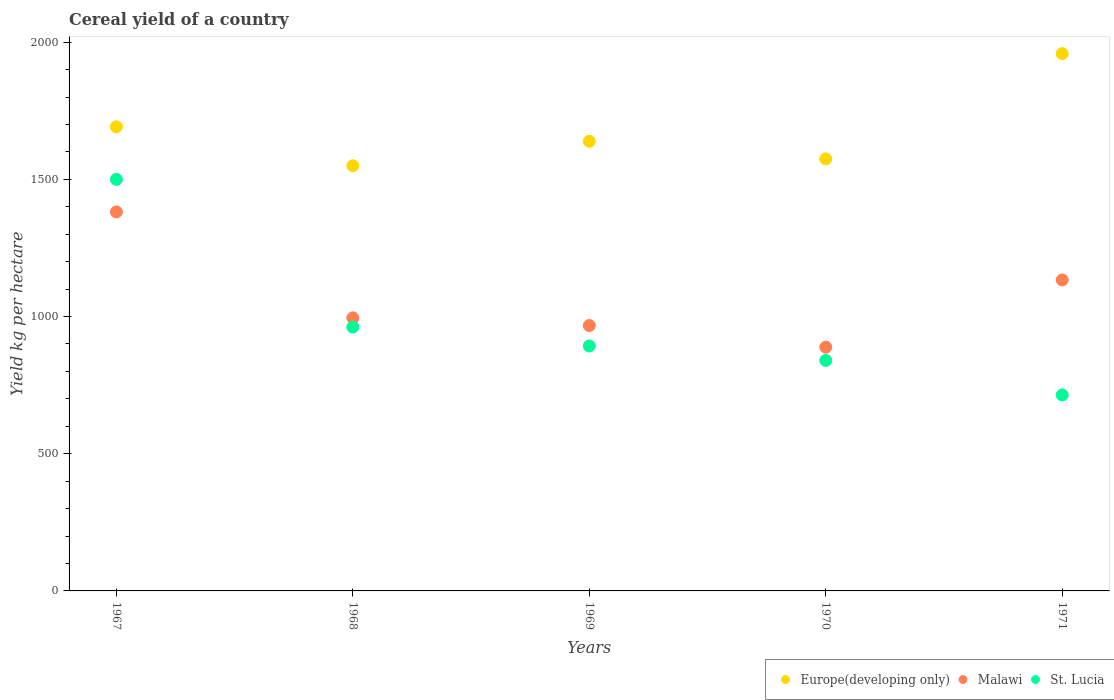Is the number of dotlines equal to the number of legend labels?
Offer a very short reply. Yes. What is the total cereal yield in Malawi in 1971?
Give a very brief answer. 1133.38. Across all years, what is the maximum total cereal yield in Malawi?
Make the answer very short. 1381.3. Across all years, what is the minimum total cereal yield in Malawi?
Your response must be concise. 888.41. In which year was the total cereal yield in Malawi maximum?
Make the answer very short. 1967. In which year was the total cereal yield in Europe(developing only) minimum?
Your response must be concise. 1968. What is the total total cereal yield in Malawi in the graph?
Provide a short and direct response. 5365.64. What is the difference between the total cereal yield in St. Lucia in 1969 and that in 1970?
Offer a terse response. 52.86. What is the difference between the total cereal yield in St. Lucia in 1971 and the total cereal yield in Europe(developing only) in 1967?
Give a very brief answer. -977.36. What is the average total cereal yield in Malawi per year?
Offer a terse response. 1073.13. In the year 1970, what is the difference between the total cereal yield in Malawi and total cereal yield in Europe(developing only)?
Offer a terse response. -686.15. In how many years, is the total cereal yield in Malawi greater than 500 kg per hectare?
Ensure brevity in your answer.  5. What is the ratio of the total cereal yield in St. Lucia in 1967 to that in 1969?
Offer a very short reply. 1.68. Is the total cereal yield in Malawi in 1969 less than that in 1971?
Your response must be concise. Yes. What is the difference between the highest and the second highest total cereal yield in Malawi?
Offer a very short reply. 247.92. What is the difference between the highest and the lowest total cereal yield in Malawi?
Offer a very short reply. 492.89. Is the sum of the total cereal yield in Malawi in 1969 and 1971 greater than the maximum total cereal yield in Europe(developing only) across all years?
Your answer should be compact. Yes. Does the total cereal yield in Europe(developing only) monotonically increase over the years?
Your answer should be compact. No. Is the total cereal yield in Europe(developing only) strictly greater than the total cereal yield in St. Lucia over the years?
Offer a terse response. Yes. What is the title of the graph?
Keep it short and to the point. Cereal yield of a country. What is the label or title of the X-axis?
Your response must be concise. Years. What is the label or title of the Y-axis?
Keep it short and to the point. Yield kg per hectare. What is the Yield kg per hectare of Europe(developing only) in 1967?
Keep it short and to the point. 1691.65. What is the Yield kg per hectare of Malawi in 1967?
Provide a succinct answer. 1381.3. What is the Yield kg per hectare of St. Lucia in 1967?
Make the answer very short. 1500. What is the Yield kg per hectare of Europe(developing only) in 1968?
Offer a terse response. 1549.55. What is the Yield kg per hectare in Malawi in 1968?
Ensure brevity in your answer.  995.26. What is the Yield kg per hectare in St. Lucia in 1968?
Your response must be concise. 961.54. What is the Yield kg per hectare in Europe(developing only) in 1969?
Offer a very short reply. 1638.79. What is the Yield kg per hectare in Malawi in 1969?
Your answer should be very brief. 967.29. What is the Yield kg per hectare in St. Lucia in 1969?
Give a very brief answer. 892.86. What is the Yield kg per hectare of Europe(developing only) in 1970?
Your answer should be compact. 1574.56. What is the Yield kg per hectare in Malawi in 1970?
Your answer should be very brief. 888.41. What is the Yield kg per hectare of St. Lucia in 1970?
Ensure brevity in your answer.  840. What is the Yield kg per hectare of Europe(developing only) in 1971?
Keep it short and to the point. 1958.18. What is the Yield kg per hectare in Malawi in 1971?
Give a very brief answer. 1133.38. What is the Yield kg per hectare in St. Lucia in 1971?
Your answer should be compact. 714.29. Across all years, what is the maximum Yield kg per hectare in Europe(developing only)?
Offer a terse response. 1958.18. Across all years, what is the maximum Yield kg per hectare of Malawi?
Offer a very short reply. 1381.3. Across all years, what is the maximum Yield kg per hectare in St. Lucia?
Make the answer very short. 1500. Across all years, what is the minimum Yield kg per hectare of Europe(developing only)?
Give a very brief answer. 1549.55. Across all years, what is the minimum Yield kg per hectare of Malawi?
Give a very brief answer. 888.41. Across all years, what is the minimum Yield kg per hectare in St. Lucia?
Provide a short and direct response. 714.29. What is the total Yield kg per hectare in Europe(developing only) in the graph?
Ensure brevity in your answer.  8412.72. What is the total Yield kg per hectare of Malawi in the graph?
Ensure brevity in your answer.  5365.64. What is the total Yield kg per hectare in St. Lucia in the graph?
Ensure brevity in your answer.  4908.68. What is the difference between the Yield kg per hectare in Europe(developing only) in 1967 and that in 1968?
Your answer should be very brief. 142.1. What is the difference between the Yield kg per hectare in Malawi in 1967 and that in 1968?
Your response must be concise. 386.05. What is the difference between the Yield kg per hectare of St. Lucia in 1967 and that in 1968?
Offer a very short reply. 538.46. What is the difference between the Yield kg per hectare in Europe(developing only) in 1967 and that in 1969?
Keep it short and to the point. 52.86. What is the difference between the Yield kg per hectare in Malawi in 1967 and that in 1969?
Your response must be concise. 414.01. What is the difference between the Yield kg per hectare in St. Lucia in 1967 and that in 1969?
Offer a terse response. 607.14. What is the difference between the Yield kg per hectare of Europe(developing only) in 1967 and that in 1970?
Make the answer very short. 117.09. What is the difference between the Yield kg per hectare of Malawi in 1967 and that in 1970?
Your answer should be compact. 492.89. What is the difference between the Yield kg per hectare of St. Lucia in 1967 and that in 1970?
Your response must be concise. 660. What is the difference between the Yield kg per hectare of Europe(developing only) in 1967 and that in 1971?
Provide a short and direct response. -266.53. What is the difference between the Yield kg per hectare of Malawi in 1967 and that in 1971?
Ensure brevity in your answer.  247.92. What is the difference between the Yield kg per hectare of St. Lucia in 1967 and that in 1971?
Ensure brevity in your answer.  785.71. What is the difference between the Yield kg per hectare of Europe(developing only) in 1968 and that in 1969?
Offer a terse response. -89.24. What is the difference between the Yield kg per hectare in Malawi in 1968 and that in 1969?
Provide a succinct answer. 27.96. What is the difference between the Yield kg per hectare in St. Lucia in 1968 and that in 1969?
Make the answer very short. 68.68. What is the difference between the Yield kg per hectare in Europe(developing only) in 1968 and that in 1970?
Provide a short and direct response. -25.01. What is the difference between the Yield kg per hectare of Malawi in 1968 and that in 1970?
Your answer should be compact. 106.85. What is the difference between the Yield kg per hectare in St. Lucia in 1968 and that in 1970?
Your answer should be very brief. 121.54. What is the difference between the Yield kg per hectare in Europe(developing only) in 1968 and that in 1971?
Offer a terse response. -408.63. What is the difference between the Yield kg per hectare in Malawi in 1968 and that in 1971?
Make the answer very short. -138.12. What is the difference between the Yield kg per hectare of St. Lucia in 1968 and that in 1971?
Your answer should be compact. 247.25. What is the difference between the Yield kg per hectare of Europe(developing only) in 1969 and that in 1970?
Give a very brief answer. 64.23. What is the difference between the Yield kg per hectare in Malawi in 1969 and that in 1970?
Your answer should be very brief. 78.88. What is the difference between the Yield kg per hectare of St. Lucia in 1969 and that in 1970?
Your response must be concise. 52.86. What is the difference between the Yield kg per hectare in Europe(developing only) in 1969 and that in 1971?
Ensure brevity in your answer.  -319.39. What is the difference between the Yield kg per hectare in Malawi in 1969 and that in 1971?
Provide a short and direct response. -166.09. What is the difference between the Yield kg per hectare of St. Lucia in 1969 and that in 1971?
Offer a very short reply. 178.57. What is the difference between the Yield kg per hectare of Europe(developing only) in 1970 and that in 1971?
Give a very brief answer. -383.62. What is the difference between the Yield kg per hectare of Malawi in 1970 and that in 1971?
Give a very brief answer. -244.97. What is the difference between the Yield kg per hectare in St. Lucia in 1970 and that in 1971?
Keep it short and to the point. 125.71. What is the difference between the Yield kg per hectare of Europe(developing only) in 1967 and the Yield kg per hectare of Malawi in 1968?
Your answer should be compact. 696.39. What is the difference between the Yield kg per hectare in Europe(developing only) in 1967 and the Yield kg per hectare in St. Lucia in 1968?
Offer a very short reply. 730.11. What is the difference between the Yield kg per hectare of Malawi in 1967 and the Yield kg per hectare of St. Lucia in 1968?
Provide a short and direct response. 419.76. What is the difference between the Yield kg per hectare of Europe(developing only) in 1967 and the Yield kg per hectare of Malawi in 1969?
Ensure brevity in your answer.  724.36. What is the difference between the Yield kg per hectare in Europe(developing only) in 1967 and the Yield kg per hectare in St. Lucia in 1969?
Make the answer very short. 798.79. What is the difference between the Yield kg per hectare in Malawi in 1967 and the Yield kg per hectare in St. Lucia in 1969?
Offer a terse response. 488.44. What is the difference between the Yield kg per hectare of Europe(developing only) in 1967 and the Yield kg per hectare of Malawi in 1970?
Give a very brief answer. 803.24. What is the difference between the Yield kg per hectare in Europe(developing only) in 1967 and the Yield kg per hectare in St. Lucia in 1970?
Offer a terse response. 851.65. What is the difference between the Yield kg per hectare in Malawi in 1967 and the Yield kg per hectare in St. Lucia in 1970?
Provide a succinct answer. 541.3. What is the difference between the Yield kg per hectare of Europe(developing only) in 1967 and the Yield kg per hectare of Malawi in 1971?
Your answer should be compact. 558.27. What is the difference between the Yield kg per hectare in Europe(developing only) in 1967 and the Yield kg per hectare in St. Lucia in 1971?
Ensure brevity in your answer.  977.36. What is the difference between the Yield kg per hectare in Malawi in 1967 and the Yield kg per hectare in St. Lucia in 1971?
Make the answer very short. 667.02. What is the difference between the Yield kg per hectare of Europe(developing only) in 1968 and the Yield kg per hectare of Malawi in 1969?
Your answer should be compact. 582.25. What is the difference between the Yield kg per hectare in Europe(developing only) in 1968 and the Yield kg per hectare in St. Lucia in 1969?
Ensure brevity in your answer.  656.69. What is the difference between the Yield kg per hectare in Malawi in 1968 and the Yield kg per hectare in St. Lucia in 1969?
Make the answer very short. 102.4. What is the difference between the Yield kg per hectare in Europe(developing only) in 1968 and the Yield kg per hectare in Malawi in 1970?
Offer a terse response. 661.14. What is the difference between the Yield kg per hectare of Europe(developing only) in 1968 and the Yield kg per hectare of St. Lucia in 1970?
Your response must be concise. 709.55. What is the difference between the Yield kg per hectare of Malawi in 1968 and the Yield kg per hectare of St. Lucia in 1970?
Make the answer very short. 155.26. What is the difference between the Yield kg per hectare of Europe(developing only) in 1968 and the Yield kg per hectare of Malawi in 1971?
Ensure brevity in your answer.  416.16. What is the difference between the Yield kg per hectare in Europe(developing only) in 1968 and the Yield kg per hectare in St. Lucia in 1971?
Give a very brief answer. 835.26. What is the difference between the Yield kg per hectare of Malawi in 1968 and the Yield kg per hectare of St. Lucia in 1971?
Offer a very short reply. 280.97. What is the difference between the Yield kg per hectare of Europe(developing only) in 1969 and the Yield kg per hectare of Malawi in 1970?
Your answer should be compact. 750.38. What is the difference between the Yield kg per hectare in Europe(developing only) in 1969 and the Yield kg per hectare in St. Lucia in 1970?
Give a very brief answer. 798.79. What is the difference between the Yield kg per hectare of Malawi in 1969 and the Yield kg per hectare of St. Lucia in 1970?
Make the answer very short. 127.29. What is the difference between the Yield kg per hectare in Europe(developing only) in 1969 and the Yield kg per hectare in Malawi in 1971?
Your answer should be very brief. 505.41. What is the difference between the Yield kg per hectare of Europe(developing only) in 1969 and the Yield kg per hectare of St. Lucia in 1971?
Give a very brief answer. 924.5. What is the difference between the Yield kg per hectare in Malawi in 1969 and the Yield kg per hectare in St. Lucia in 1971?
Keep it short and to the point. 253.01. What is the difference between the Yield kg per hectare in Europe(developing only) in 1970 and the Yield kg per hectare in Malawi in 1971?
Give a very brief answer. 441.17. What is the difference between the Yield kg per hectare in Europe(developing only) in 1970 and the Yield kg per hectare in St. Lucia in 1971?
Your answer should be compact. 860.27. What is the difference between the Yield kg per hectare in Malawi in 1970 and the Yield kg per hectare in St. Lucia in 1971?
Provide a succinct answer. 174.12. What is the average Yield kg per hectare of Europe(developing only) per year?
Your response must be concise. 1682.54. What is the average Yield kg per hectare of Malawi per year?
Make the answer very short. 1073.13. What is the average Yield kg per hectare in St. Lucia per year?
Provide a short and direct response. 981.74. In the year 1967, what is the difference between the Yield kg per hectare of Europe(developing only) and Yield kg per hectare of Malawi?
Provide a short and direct response. 310.35. In the year 1967, what is the difference between the Yield kg per hectare in Europe(developing only) and Yield kg per hectare in St. Lucia?
Your response must be concise. 191.65. In the year 1967, what is the difference between the Yield kg per hectare of Malawi and Yield kg per hectare of St. Lucia?
Give a very brief answer. -118.7. In the year 1968, what is the difference between the Yield kg per hectare in Europe(developing only) and Yield kg per hectare in Malawi?
Offer a very short reply. 554.29. In the year 1968, what is the difference between the Yield kg per hectare of Europe(developing only) and Yield kg per hectare of St. Lucia?
Make the answer very short. 588.01. In the year 1968, what is the difference between the Yield kg per hectare in Malawi and Yield kg per hectare in St. Lucia?
Your answer should be very brief. 33.72. In the year 1969, what is the difference between the Yield kg per hectare of Europe(developing only) and Yield kg per hectare of Malawi?
Your response must be concise. 671.5. In the year 1969, what is the difference between the Yield kg per hectare of Europe(developing only) and Yield kg per hectare of St. Lucia?
Give a very brief answer. 745.93. In the year 1969, what is the difference between the Yield kg per hectare in Malawi and Yield kg per hectare in St. Lucia?
Provide a short and direct response. 74.44. In the year 1970, what is the difference between the Yield kg per hectare of Europe(developing only) and Yield kg per hectare of Malawi?
Your answer should be very brief. 686.15. In the year 1970, what is the difference between the Yield kg per hectare of Europe(developing only) and Yield kg per hectare of St. Lucia?
Your answer should be compact. 734.56. In the year 1970, what is the difference between the Yield kg per hectare in Malawi and Yield kg per hectare in St. Lucia?
Keep it short and to the point. 48.41. In the year 1971, what is the difference between the Yield kg per hectare of Europe(developing only) and Yield kg per hectare of Malawi?
Make the answer very short. 824.8. In the year 1971, what is the difference between the Yield kg per hectare of Europe(developing only) and Yield kg per hectare of St. Lucia?
Offer a terse response. 1243.89. In the year 1971, what is the difference between the Yield kg per hectare of Malawi and Yield kg per hectare of St. Lucia?
Your answer should be very brief. 419.1. What is the ratio of the Yield kg per hectare in Europe(developing only) in 1967 to that in 1968?
Offer a terse response. 1.09. What is the ratio of the Yield kg per hectare in Malawi in 1967 to that in 1968?
Keep it short and to the point. 1.39. What is the ratio of the Yield kg per hectare of St. Lucia in 1967 to that in 1968?
Provide a short and direct response. 1.56. What is the ratio of the Yield kg per hectare of Europe(developing only) in 1967 to that in 1969?
Provide a short and direct response. 1.03. What is the ratio of the Yield kg per hectare in Malawi in 1967 to that in 1969?
Make the answer very short. 1.43. What is the ratio of the Yield kg per hectare of St. Lucia in 1967 to that in 1969?
Give a very brief answer. 1.68. What is the ratio of the Yield kg per hectare of Europe(developing only) in 1967 to that in 1970?
Ensure brevity in your answer.  1.07. What is the ratio of the Yield kg per hectare of Malawi in 1967 to that in 1970?
Your answer should be very brief. 1.55. What is the ratio of the Yield kg per hectare of St. Lucia in 1967 to that in 1970?
Make the answer very short. 1.79. What is the ratio of the Yield kg per hectare in Europe(developing only) in 1967 to that in 1971?
Provide a short and direct response. 0.86. What is the ratio of the Yield kg per hectare in Malawi in 1967 to that in 1971?
Offer a terse response. 1.22. What is the ratio of the Yield kg per hectare in Europe(developing only) in 1968 to that in 1969?
Ensure brevity in your answer.  0.95. What is the ratio of the Yield kg per hectare of Malawi in 1968 to that in 1969?
Offer a very short reply. 1.03. What is the ratio of the Yield kg per hectare in St. Lucia in 1968 to that in 1969?
Your response must be concise. 1.08. What is the ratio of the Yield kg per hectare in Europe(developing only) in 1968 to that in 1970?
Your response must be concise. 0.98. What is the ratio of the Yield kg per hectare in Malawi in 1968 to that in 1970?
Your response must be concise. 1.12. What is the ratio of the Yield kg per hectare of St. Lucia in 1968 to that in 1970?
Give a very brief answer. 1.14. What is the ratio of the Yield kg per hectare of Europe(developing only) in 1968 to that in 1971?
Your answer should be compact. 0.79. What is the ratio of the Yield kg per hectare in Malawi in 1968 to that in 1971?
Your answer should be compact. 0.88. What is the ratio of the Yield kg per hectare of St. Lucia in 1968 to that in 1971?
Your answer should be very brief. 1.35. What is the ratio of the Yield kg per hectare in Europe(developing only) in 1969 to that in 1970?
Give a very brief answer. 1.04. What is the ratio of the Yield kg per hectare in Malawi in 1969 to that in 1970?
Ensure brevity in your answer.  1.09. What is the ratio of the Yield kg per hectare of St. Lucia in 1969 to that in 1970?
Offer a terse response. 1.06. What is the ratio of the Yield kg per hectare of Europe(developing only) in 1969 to that in 1971?
Offer a very short reply. 0.84. What is the ratio of the Yield kg per hectare of Malawi in 1969 to that in 1971?
Ensure brevity in your answer.  0.85. What is the ratio of the Yield kg per hectare in Europe(developing only) in 1970 to that in 1971?
Provide a short and direct response. 0.8. What is the ratio of the Yield kg per hectare in Malawi in 1970 to that in 1971?
Your answer should be compact. 0.78. What is the ratio of the Yield kg per hectare of St. Lucia in 1970 to that in 1971?
Your response must be concise. 1.18. What is the difference between the highest and the second highest Yield kg per hectare of Europe(developing only)?
Give a very brief answer. 266.53. What is the difference between the highest and the second highest Yield kg per hectare in Malawi?
Offer a terse response. 247.92. What is the difference between the highest and the second highest Yield kg per hectare in St. Lucia?
Make the answer very short. 538.46. What is the difference between the highest and the lowest Yield kg per hectare in Europe(developing only)?
Give a very brief answer. 408.63. What is the difference between the highest and the lowest Yield kg per hectare in Malawi?
Offer a terse response. 492.89. What is the difference between the highest and the lowest Yield kg per hectare in St. Lucia?
Your answer should be very brief. 785.71. 